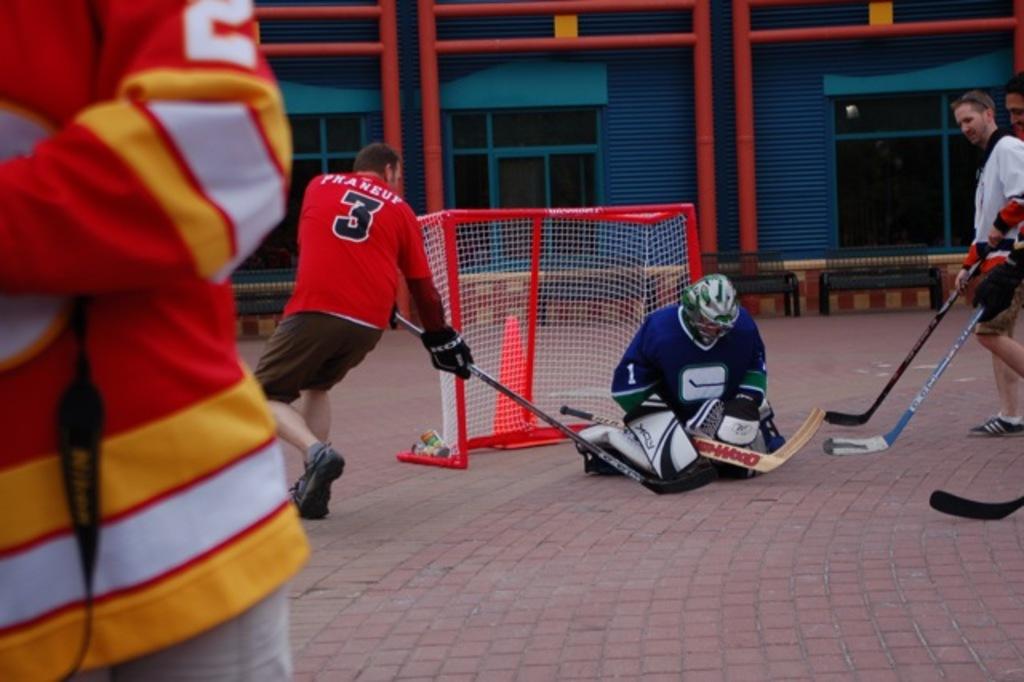What number is on the red jersey?
Your answer should be very brief. 3. 